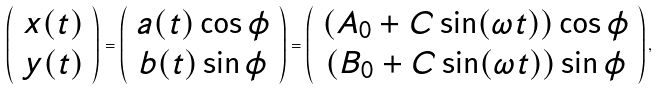<formula> <loc_0><loc_0><loc_500><loc_500>\left ( \begin{array} { c } x ( t ) \\ y ( t ) \\ \end{array} \right ) = \left ( \begin{array} { c } a ( t ) \cos \phi \\ b ( t ) \sin \phi \\ \end{array} \right ) = \left ( \begin{array} { c } ( A _ { 0 } + C \sin ( \omega t ) ) \cos \phi \\ ( B _ { 0 } + C \sin ( \omega t ) ) \sin \phi \\ \end{array} \right ) ,</formula> 